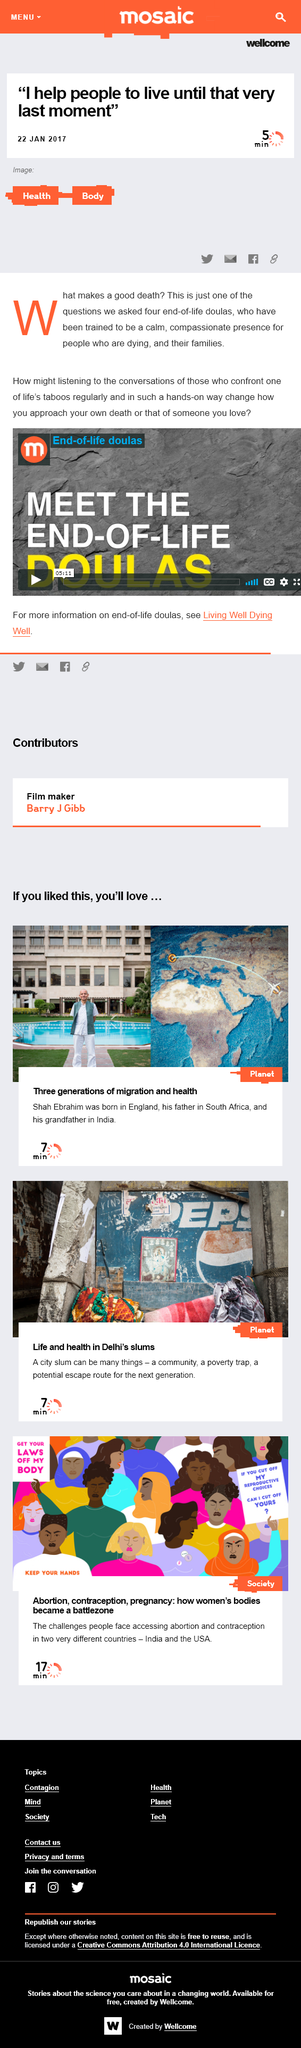Outline some significant characteristics in this image. The two words in the image are "Health" and "Body". The article interviewed four Doulas. Four Doulas were interviewed by the article. The interview conversation is 5 minutes long and has been ongoing for an undetermined amount of time. 